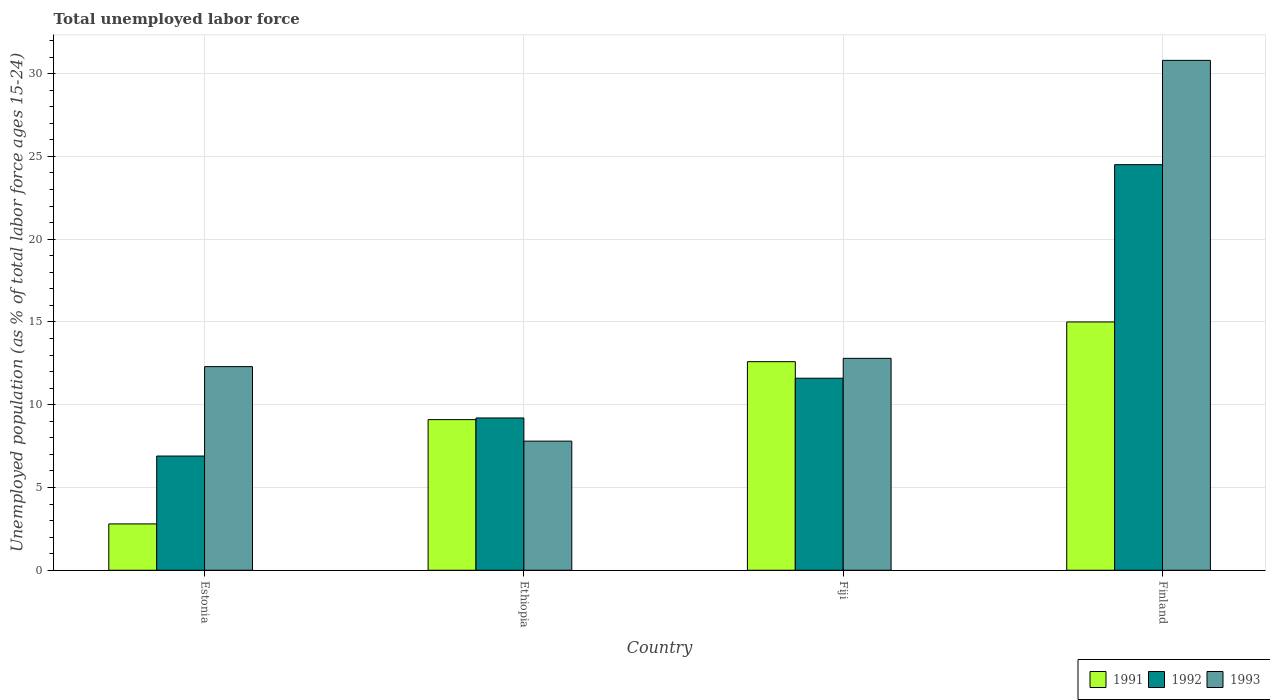Are the number of bars per tick equal to the number of legend labels?
Your answer should be compact. Yes. Are the number of bars on each tick of the X-axis equal?
Give a very brief answer. Yes. How many bars are there on the 3rd tick from the left?
Give a very brief answer. 3. How many bars are there on the 2nd tick from the right?
Give a very brief answer. 3. What is the label of the 3rd group of bars from the left?
Offer a very short reply. Fiji. In how many cases, is the number of bars for a given country not equal to the number of legend labels?
Make the answer very short. 0. What is the percentage of unemployed population in in 1993 in Ethiopia?
Make the answer very short. 7.8. Across all countries, what is the minimum percentage of unemployed population in in 1992?
Your response must be concise. 6.9. In which country was the percentage of unemployed population in in 1993 maximum?
Offer a very short reply. Finland. In which country was the percentage of unemployed population in in 1993 minimum?
Give a very brief answer. Ethiopia. What is the total percentage of unemployed population in in 1991 in the graph?
Your answer should be compact. 39.5. What is the difference between the percentage of unemployed population in in 1993 in Estonia and that in Ethiopia?
Offer a terse response. 4.5. What is the difference between the percentage of unemployed population in in 1993 in Estonia and the percentage of unemployed population in in 1992 in Ethiopia?
Your answer should be very brief. 3.1. What is the average percentage of unemployed population in in 1993 per country?
Offer a terse response. 15.92. What is the difference between the percentage of unemployed population in of/in 1991 and percentage of unemployed population in of/in 1993 in Fiji?
Provide a short and direct response. -0.2. In how many countries, is the percentage of unemployed population in in 1991 greater than 24 %?
Give a very brief answer. 0. What is the ratio of the percentage of unemployed population in in 1992 in Fiji to that in Finland?
Offer a very short reply. 0.47. Is the difference between the percentage of unemployed population in in 1991 in Estonia and Fiji greater than the difference between the percentage of unemployed population in in 1993 in Estonia and Fiji?
Offer a terse response. No. What is the difference between the highest and the second highest percentage of unemployed population in in 1992?
Ensure brevity in your answer.  15.3. What is the difference between the highest and the lowest percentage of unemployed population in in 1991?
Offer a very short reply. 12.2. Is it the case that in every country, the sum of the percentage of unemployed population in in 1993 and percentage of unemployed population in in 1991 is greater than the percentage of unemployed population in in 1992?
Your answer should be very brief. Yes. How many bars are there?
Offer a terse response. 12. What is the difference between two consecutive major ticks on the Y-axis?
Give a very brief answer. 5. Are the values on the major ticks of Y-axis written in scientific E-notation?
Offer a terse response. No. How are the legend labels stacked?
Give a very brief answer. Horizontal. What is the title of the graph?
Your answer should be very brief. Total unemployed labor force. What is the label or title of the X-axis?
Your answer should be very brief. Country. What is the label or title of the Y-axis?
Provide a succinct answer. Unemployed population (as % of total labor force ages 15-24). What is the Unemployed population (as % of total labor force ages 15-24) of 1991 in Estonia?
Your answer should be compact. 2.8. What is the Unemployed population (as % of total labor force ages 15-24) in 1992 in Estonia?
Keep it short and to the point. 6.9. What is the Unemployed population (as % of total labor force ages 15-24) in 1993 in Estonia?
Provide a succinct answer. 12.3. What is the Unemployed population (as % of total labor force ages 15-24) of 1991 in Ethiopia?
Provide a short and direct response. 9.1. What is the Unemployed population (as % of total labor force ages 15-24) of 1992 in Ethiopia?
Your answer should be compact. 9.2. What is the Unemployed population (as % of total labor force ages 15-24) of 1993 in Ethiopia?
Your response must be concise. 7.8. What is the Unemployed population (as % of total labor force ages 15-24) in 1991 in Fiji?
Keep it short and to the point. 12.6. What is the Unemployed population (as % of total labor force ages 15-24) in 1992 in Fiji?
Keep it short and to the point. 11.6. What is the Unemployed population (as % of total labor force ages 15-24) of 1993 in Fiji?
Keep it short and to the point. 12.8. What is the Unemployed population (as % of total labor force ages 15-24) of 1991 in Finland?
Provide a succinct answer. 15. What is the Unemployed population (as % of total labor force ages 15-24) of 1992 in Finland?
Ensure brevity in your answer.  24.5. What is the Unemployed population (as % of total labor force ages 15-24) of 1993 in Finland?
Provide a short and direct response. 30.8. Across all countries, what is the maximum Unemployed population (as % of total labor force ages 15-24) in 1991?
Offer a very short reply. 15. Across all countries, what is the maximum Unemployed population (as % of total labor force ages 15-24) of 1993?
Your answer should be very brief. 30.8. Across all countries, what is the minimum Unemployed population (as % of total labor force ages 15-24) of 1991?
Make the answer very short. 2.8. Across all countries, what is the minimum Unemployed population (as % of total labor force ages 15-24) of 1992?
Offer a very short reply. 6.9. Across all countries, what is the minimum Unemployed population (as % of total labor force ages 15-24) of 1993?
Your answer should be very brief. 7.8. What is the total Unemployed population (as % of total labor force ages 15-24) in 1991 in the graph?
Provide a succinct answer. 39.5. What is the total Unemployed population (as % of total labor force ages 15-24) in 1992 in the graph?
Give a very brief answer. 52.2. What is the total Unemployed population (as % of total labor force ages 15-24) of 1993 in the graph?
Give a very brief answer. 63.7. What is the difference between the Unemployed population (as % of total labor force ages 15-24) in 1991 in Estonia and that in Ethiopia?
Ensure brevity in your answer.  -6.3. What is the difference between the Unemployed population (as % of total labor force ages 15-24) of 1992 in Estonia and that in Ethiopia?
Your answer should be very brief. -2.3. What is the difference between the Unemployed population (as % of total labor force ages 15-24) of 1993 in Estonia and that in Ethiopia?
Your response must be concise. 4.5. What is the difference between the Unemployed population (as % of total labor force ages 15-24) of 1991 in Estonia and that in Fiji?
Offer a terse response. -9.8. What is the difference between the Unemployed population (as % of total labor force ages 15-24) of 1993 in Estonia and that in Fiji?
Your response must be concise. -0.5. What is the difference between the Unemployed population (as % of total labor force ages 15-24) in 1992 in Estonia and that in Finland?
Your answer should be very brief. -17.6. What is the difference between the Unemployed population (as % of total labor force ages 15-24) of 1993 in Estonia and that in Finland?
Give a very brief answer. -18.5. What is the difference between the Unemployed population (as % of total labor force ages 15-24) of 1991 in Ethiopia and that in Fiji?
Ensure brevity in your answer.  -3.5. What is the difference between the Unemployed population (as % of total labor force ages 15-24) of 1993 in Ethiopia and that in Fiji?
Make the answer very short. -5. What is the difference between the Unemployed population (as % of total labor force ages 15-24) of 1992 in Ethiopia and that in Finland?
Your answer should be compact. -15.3. What is the difference between the Unemployed population (as % of total labor force ages 15-24) in 1991 in Fiji and that in Finland?
Keep it short and to the point. -2.4. What is the difference between the Unemployed population (as % of total labor force ages 15-24) of 1991 in Estonia and the Unemployed population (as % of total labor force ages 15-24) of 1992 in Ethiopia?
Give a very brief answer. -6.4. What is the difference between the Unemployed population (as % of total labor force ages 15-24) of 1991 in Estonia and the Unemployed population (as % of total labor force ages 15-24) of 1993 in Ethiopia?
Make the answer very short. -5. What is the difference between the Unemployed population (as % of total labor force ages 15-24) in 1992 in Estonia and the Unemployed population (as % of total labor force ages 15-24) in 1993 in Ethiopia?
Offer a terse response. -0.9. What is the difference between the Unemployed population (as % of total labor force ages 15-24) in 1991 in Estonia and the Unemployed population (as % of total labor force ages 15-24) in 1992 in Fiji?
Your response must be concise. -8.8. What is the difference between the Unemployed population (as % of total labor force ages 15-24) of 1991 in Estonia and the Unemployed population (as % of total labor force ages 15-24) of 1992 in Finland?
Your response must be concise. -21.7. What is the difference between the Unemployed population (as % of total labor force ages 15-24) of 1991 in Estonia and the Unemployed population (as % of total labor force ages 15-24) of 1993 in Finland?
Give a very brief answer. -28. What is the difference between the Unemployed population (as % of total labor force ages 15-24) in 1992 in Estonia and the Unemployed population (as % of total labor force ages 15-24) in 1993 in Finland?
Your answer should be compact. -23.9. What is the difference between the Unemployed population (as % of total labor force ages 15-24) of 1991 in Ethiopia and the Unemployed population (as % of total labor force ages 15-24) of 1992 in Finland?
Keep it short and to the point. -15.4. What is the difference between the Unemployed population (as % of total labor force ages 15-24) in 1991 in Ethiopia and the Unemployed population (as % of total labor force ages 15-24) in 1993 in Finland?
Your answer should be very brief. -21.7. What is the difference between the Unemployed population (as % of total labor force ages 15-24) of 1992 in Ethiopia and the Unemployed population (as % of total labor force ages 15-24) of 1993 in Finland?
Provide a succinct answer. -21.6. What is the difference between the Unemployed population (as % of total labor force ages 15-24) in 1991 in Fiji and the Unemployed population (as % of total labor force ages 15-24) in 1992 in Finland?
Keep it short and to the point. -11.9. What is the difference between the Unemployed population (as % of total labor force ages 15-24) of 1991 in Fiji and the Unemployed population (as % of total labor force ages 15-24) of 1993 in Finland?
Offer a terse response. -18.2. What is the difference between the Unemployed population (as % of total labor force ages 15-24) in 1992 in Fiji and the Unemployed population (as % of total labor force ages 15-24) in 1993 in Finland?
Your answer should be very brief. -19.2. What is the average Unemployed population (as % of total labor force ages 15-24) of 1991 per country?
Ensure brevity in your answer.  9.88. What is the average Unemployed population (as % of total labor force ages 15-24) of 1992 per country?
Keep it short and to the point. 13.05. What is the average Unemployed population (as % of total labor force ages 15-24) in 1993 per country?
Offer a terse response. 15.93. What is the difference between the Unemployed population (as % of total labor force ages 15-24) in 1991 and Unemployed population (as % of total labor force ages 15-24) in 1992 in Estonia?
Provide a short and direct response. -4.1. What is the difference between the Unemployed population (as % of total labor force ages 15-24) of 1991 and Unemployed population (as % of total labor force ages 15-24) of 1993 in Estonia?
Your answer should be compact. -9.5. What is the difference between the Unemployed population (as % of total labor force ages 15-24) in 1992 and Unemployed population (as % of total labor force ages 15-24) in 1993 in Estonia?
Your response must be concise. -5.4. What is the difference between the Unemployed population (as % of total labor force ages 15-24) in 1991 and Unemployed population (as % of total labor force ages 15-24) in 1992 in Ethiopia?
Your answer should be very brief. -0.1. What is the difference between the Unemployed population (as % of total labor force ages 15-24) of 1991 and Unemployed population (as % of total labor force ages 15-24) of 1993 in Fiji?
Provide a short and direct response. -0.2. What is the difference between the Unemployed population (as % of total labor force ages 15-24) of 1991 and Unemployed population (as % of total labor force ages 15-24) of 1993 in Finland?
Give a very brief answer. -15.8. What is the difference between the Unemployed population (as % of total labor force ages 15-24) in 1992 and Unemployed population (as % of total labor force ages 15-24) in 1993 in Finland?
Give a very brief answer. -6.3. What is the ratio of the Unemployed population (as % of total labor force ages 15-24) of 1991 in Estonia to that in Ethiopia?
Your answer should be very brief. 0.31. What is the ratio of the Unemployed population (as % of total labor force ages 15-24) in 1993 in Estonia to that in Ethiopia?
Provide a short and direct response. 1.58. What is the ratio of the Unemployed population (as % of total labor force ages 15-24) of 1991 in Estonia to that in Fiji?
Provide a succinct answer. 0.22. What is the ratio of the Unemployed population (as % of total labor force ages 15-24) of 1992 in Estonia to that in Fiji?
Your response must be concise. 0.59. What is the ratio of the Unemployed population (as % of total labor force ages 15-24) in 1993 in Estonia to that in Fiji?
Your answer should be very brief. 0.96. What is the ratio of the Unemployed population (as % of total labor force ages 15-24) of 1991 in Estonia to that in Finland?
Provide a succinct answer. 0.19. What is the ratio of the Unemployed population (as % of total labor force ages 15-24) of 1992 in Estonia to that in Finland?
Keep it short and to the point. 0.28. What is the ratio of the Unemployed population (as % of total labor force ages 15-24) of 1993 in Estonia to that in Finland?
Your response must be concise. 0.4. What is the ratio of the Unemployed population (as % of total labor force ages 15-24) in 1991 in Ethiopia to that in Fiji?
Offer a terse response. 0.72. What is the ratio of the Unemployed population (as % of total labor force ages 15-24) of 1992 in Ethiopia to that in Fiji?
Offer a terse response. 0.79. What is the ratio of the Unemployed population (as % of total labor force ages 15-24) in 1993 in Ethiopia to that in Fiji?
Provide a short and direct response. 0.61. What is the ratio of the Unemployed population (as % of total labor force ages 15-24) in 1991 in Ethiopia to that in Finland?
Offer a very short reply. 0.61. What is the ratio of the Unemployed population (as % of total labor force ages 15-24) of 1992 in Ethiopia to that in Finland?
Your response must be concise. 0.38. What is the ratio of the Unemployed population (as % of total labor force ages 15-24) of 1993 in Ethiopia to that in Finland?
Provide a short and direct response. 0.25. What is the ratio of the Unemployed population (as % of total labor force ages 15-24) of 1991 in Fiji to that in Finland?
Your answer should be compact. 0.84. What is the ratio of the Unemployed population (as % of total labor force ages 15-24) in 1992 in Fiji to that in Finland?
Give a very brief answer. 0.47. What is the ratio of the Unemployed population (as % of total labor force ages 15-24) of 1993 in Fiji to that in Finland?
Give a very brief answer. 0.42. What is the difference between the highest and the second highest Unemployed population (as % of total labor force ages 15-24) of 1992?
Your answer should be compact. 12.9. What is the difference between the highest and the lowest Unemployed population (as % of total labor force ages 15-24) of 1992?
Keep it short and to the point. 17.6. 